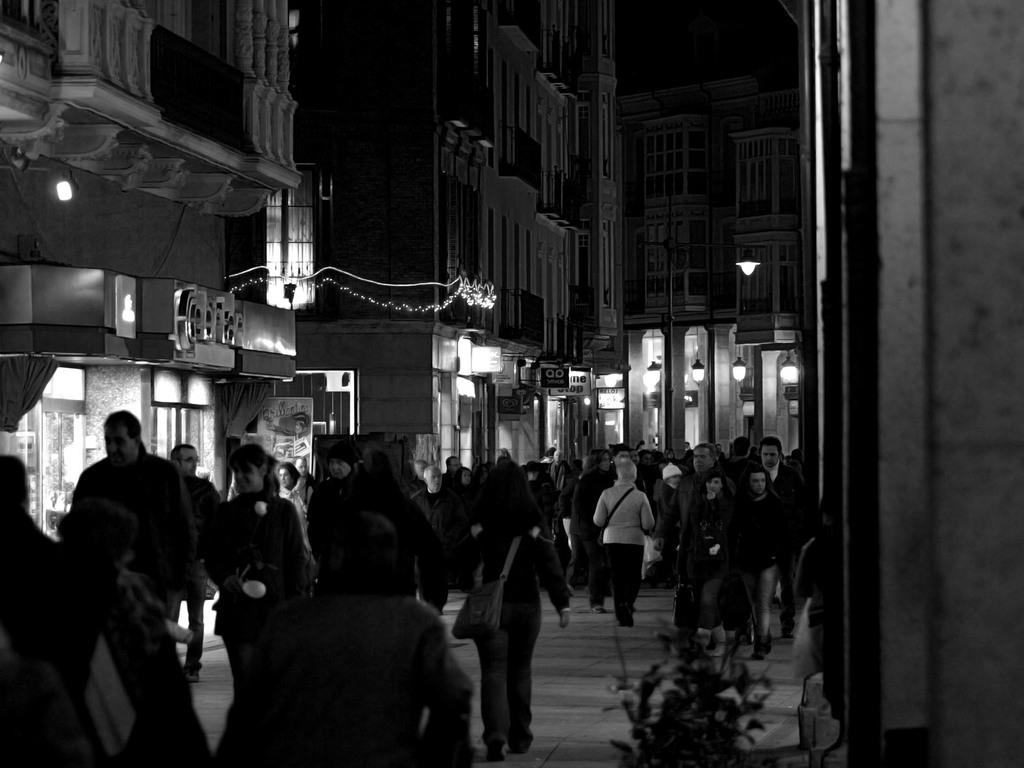What is happening with the group of people in the image? The people are walking in the image. What are the people wearing that might be used for carrying items? The people are wearing bags in the image. What type of structures can be seen in the background of the image? There are buildings visible in the image. What objects are present in the image that provide illumination? Light poles are present in the image. What type of signage or information can be seen in the image? There are boards in the image. How does the haircut on the light pole look in the image? There is no haircut present in the image; it is a light pole, not a person getting a haircut. 